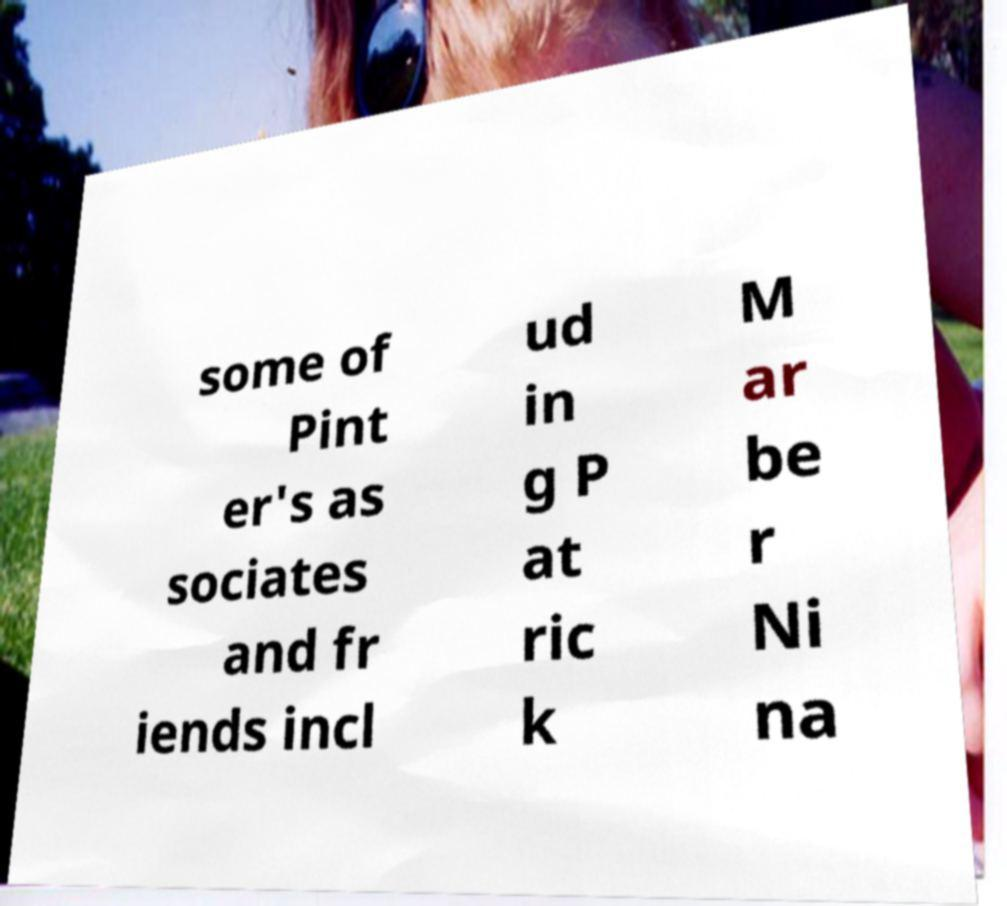Please identify and transcribe the text found in this image. some of Pint er's as sociates and fr iends incl ud in g P at ric k M ar be r Ni na 